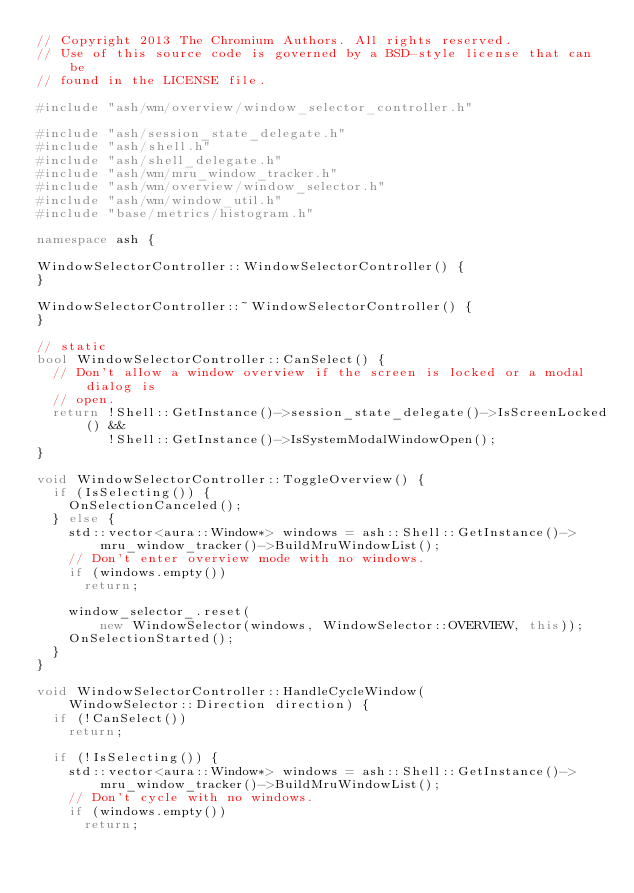Convert code to text. <code><loc_0><loc_0><loc_500><loc_500><_C++_>// Copyright 2013 The Chromium Authors. All rights reserved.
// Use of this source code is governed by a BSD-style license that can be
// found in the LICENSE file.

#include "ash/wm/overview/window_selector_controller.h"

#include "ash/session_state_delegate.h"
#include "ash/shell.h"
#include "ash/shell_delegate.h"
#include "ash/wm/mru_window_tracker.h"
#include "ash/wm/overview/window_selector.h"
#include "ash/wm/window_util.h"
#include "base/metrics/histogram.h"

namespace ash {

WindowSelectorController::WindowSelectorController() {
}

WindowSelectorController::~WindowSelectorController() {
}

// static
bool WindowSelectorController::CanSelect() {
  // Don't allow a window overview if the screen is locked or a modal dialog is
  // open.
  return !Shell::GetInstance()->session_state_delegate()->IsScreenLocked() &&
         !Shell::GetInstance()->IsSystemModalWindowOpen();
}

void WindowSelectorController::ToggleOverview() {
  if (IsSelecting()) {
    OnSelectionCanceled();
  } else {
    std::vector<aura::Window*> windows = ash::Shell::GetInstance()->
        mru_window_tracker()->BuildMruWindowList();
    // Don't enter overview mode with no windows.
    if (windows.empty())
      return;

    window_selector_.reset(
        new WindowSelector(windows, WindowSelector::OVERVIEW, this));
    OnSelectionStarted();
  }
}

void WindowSelectorController::HandleCycleWindow(
    WindowSelector::Direction direction) {
  if (!CanSelect())
    return;

  if (!IsSelecting()) {
    std::vector<aura::Window*> windows = ash::Shell::GetInstance()->
        mru_window_tracker()->BuildMruWindowList();
    // Don't cycle with no windows.
    if (windows.empty())
      return;
</code> 